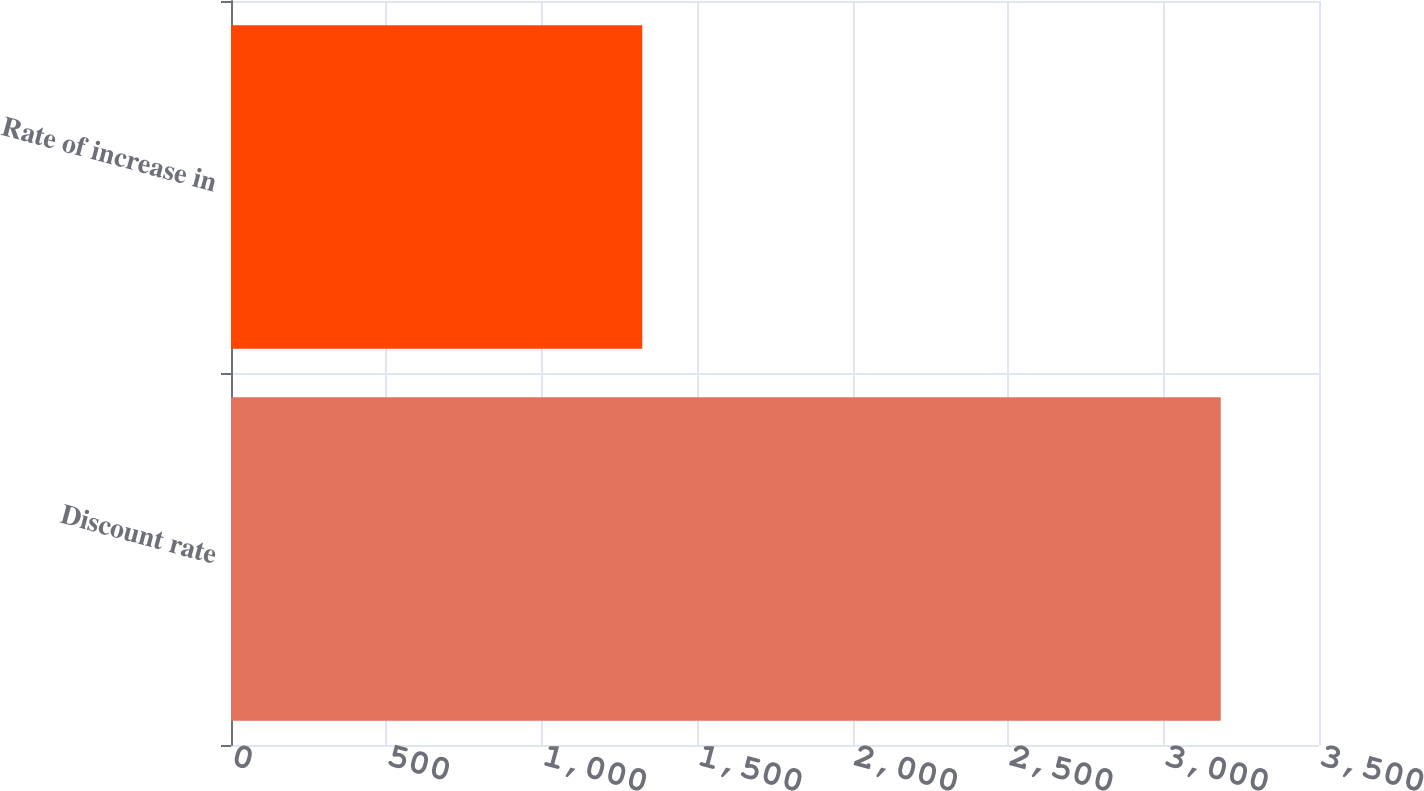<chart> <loc_0><loc_0><loc_500><loc_500><bar_chart><fcel>Discount rate<fcel>Rate of increase in<nl><fcel>3184<fcel>1323<nl></chart> 